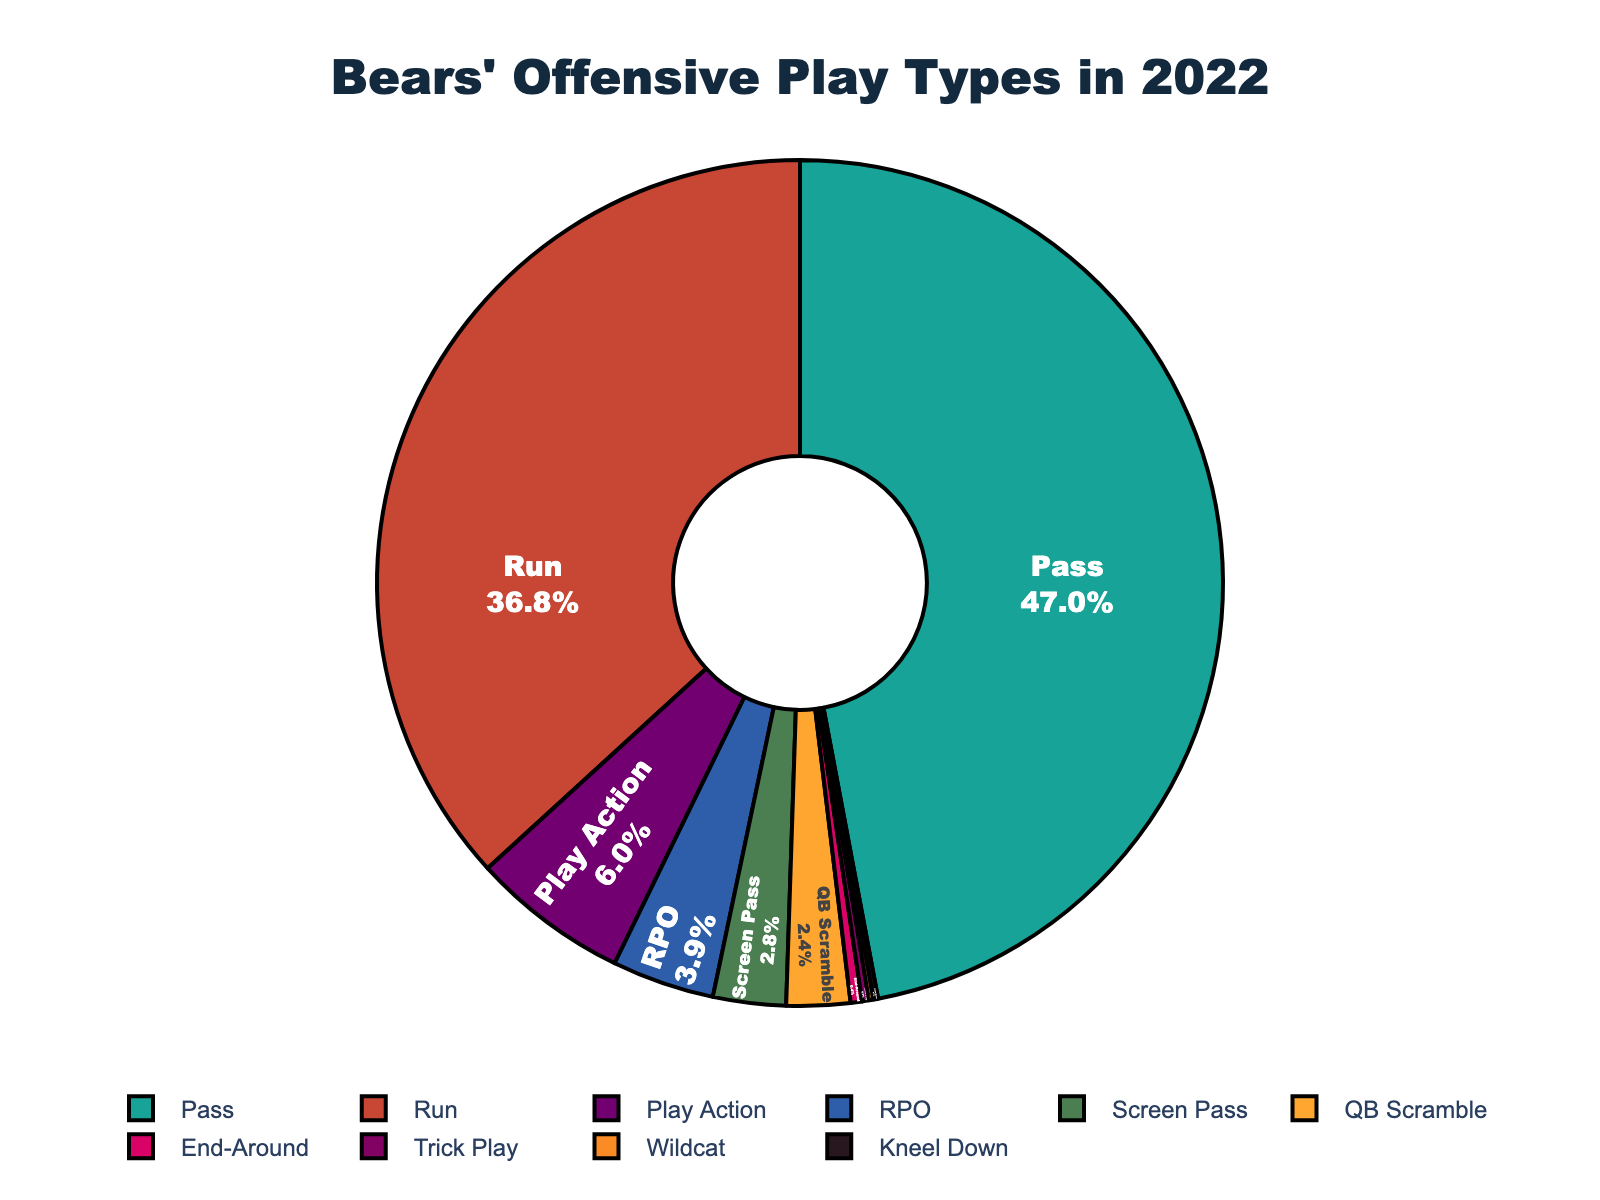What's the most common offensive play type for the Bears in 2022? The pie chart shows the play types with their respective percentages. The segment with the largest percentage represents the most common play type. The "Pass" play type has the highest percentage at 54.1%.
Answer: Pass What's the total combined percentage of Play Action, RPO, and End-Around play types? From the pie chart, we can identify the percentages of Play Action (6.9%), RPO (4.5%), and End-Around (0.5%). Summing these percentages gives us 6.9 + 4.5 + 0.5 = 11.9%.
Answer: 11.9% How does the percentage of Run plays compare to Pass plays? By examining the pie chart, we find the percentage for Run plays is 42.3% and for Pass plays is 54.1%. Pass plays are a higher percentage.
Answer: Pass plays are higher What is the difference in percentage between QB Scramble and Wildcat play types? From the pie chart, the percentage for QB Scramble is 2.8% and for Wildcat is 0.2%. Subtracting these gives 2.8 - 0.2 = 2.6%.
Answer: 2.6% Which play type associated with trickery or misdirection has the lowest usage? Looking at the pie chart, the Trick Play type has a percentage of 0.3%, which is the lowest among the listed play types involving trickery or misdirection.
Answer: Trick Play What’s the combined percentage of the least common three play types? The pie chart shows the least common play types as Wildcat (0.2%), Kneel Down (0.2%), and End-Around (0.5%). Summing these gives 0.2 + 0.2 + 0.5 = 0.9%.
Answer: 0.9% Does the percentage of Screen Passes exceed that of Play Action plays? From the pie chart, Screen Passes have a percentage of 3.2% and Play Action has 6.9%. Screen Passes are less than Play Action.
Answer: No What is the visual representation color of the play type with the second-highest percentage? The pie chart’s segment for the second-highest percentage, which is Run (42.3%), is represented by the color red.
Answer: Red What's the sum of the percentage for all play types excluding Run and Pass? We need to sum the percentages for all play types other than Run (42.3%) and Pass (54.1%): Screen Pass (3.2%), QB Scramble (2.8%), Play Action (6.9%), RPO (4.5%), Wildcat (0.2%), End-Around (0.5%), Trick Play (0.3%), and Kneel Down (0.2%). Adding these gives 3.2 + 2.8 + 6.9 + 4.5 + 0.2 + 0.5 + 0.3 + 0.2 = 18.6%.
Answer: 18.6% Between the play types categorized as "pass-related" (Pass, Screen Pass, Play Action, RPO), which is the least common? From the pie chart, the percentages for the pass-related play types are Pass (54.1%), Screen Pass (3.2%), Play Action (6.9%), and RPO (4.5%). Screen Pass has the lowest percentage.
Answer: Screen Pass 